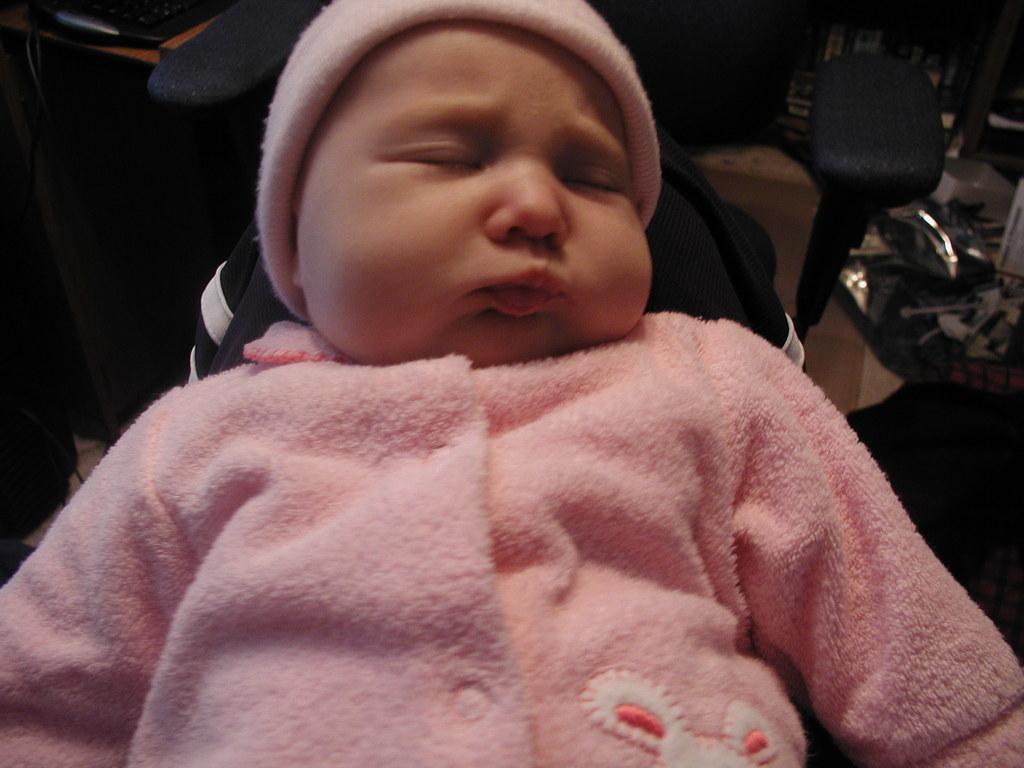In one or two sentences, can you explain what this image depicts? In the center of the image we can see a baby wearing the cap and also the pink color dress and the background is not clear. 